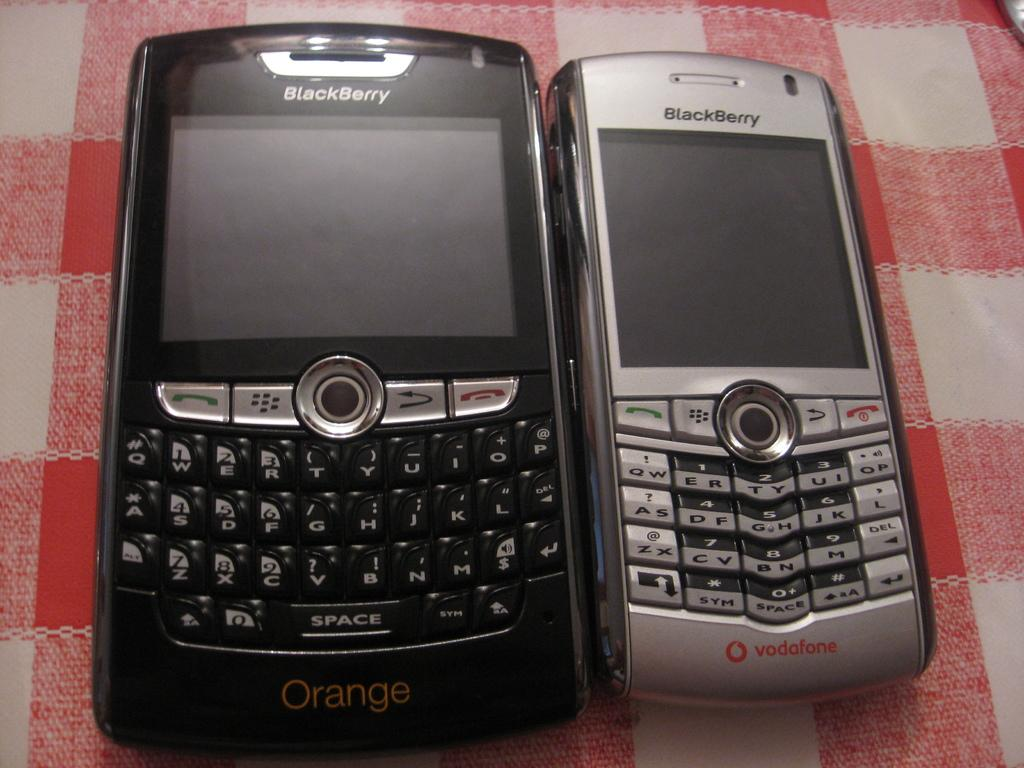<image>
Render a clear and concise summary of the photo. The Orange model BlackBerry phone is a lot wider than the Vodafone model. 